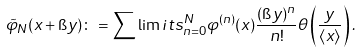<formula> <loc_0><loc_0><loc_500><loc_500>\tilde { \varphi } _ { N } ( x + \i y ) \colon = \sum \lim i t s _ { n = 0 } ^ { N } \varphi ^ { ( n ) } ( x ) \frac { ( \i y ) ^ { n } } { n ! } \theta \left ( \frac { y } { \langle x \rangle } \right ) .</formula> 